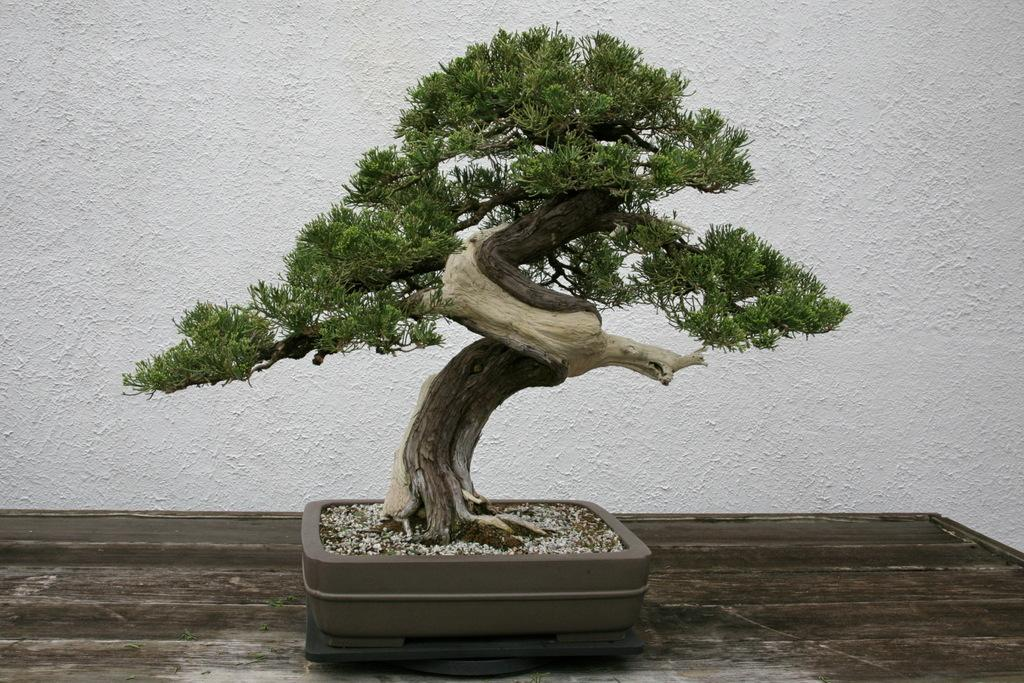What type of plant can be seen in the image? There is a tree in the image. What can be seen in the background of the image? There is a wall visible in the background of the image. What letter is the rat holding in the image? There is no rat or letter present in the image. 